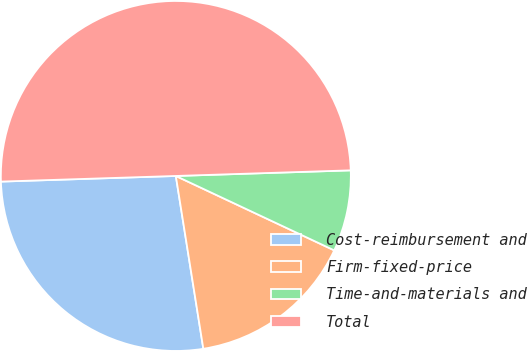<chart> <loc_0><loc_0><loc_500><loc_500><pie_chart><fcel>Cost-reimbursement and<fcel>Firm-fixed-price<fcel>Time-and-materials and<fcel>Total<nl><fcel>27.0%<fcel>15.5%<fcel>7.5%<fcel>50.0%<nl></chart> 